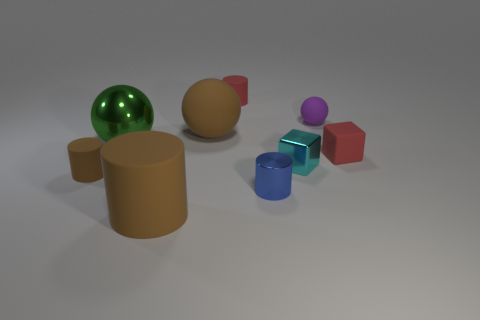Does the large object that is in front of the large green thing have the same material as the small cylinder behind the tiny brown cylinder? While a visual inspection might suggest that the large object in front of the green sphere and the small cylinder behind the tiny brown object have similar surface qualities, without additional information regarding texture, weight, and composition, one cannot definitively determine if they are made of the same material. 